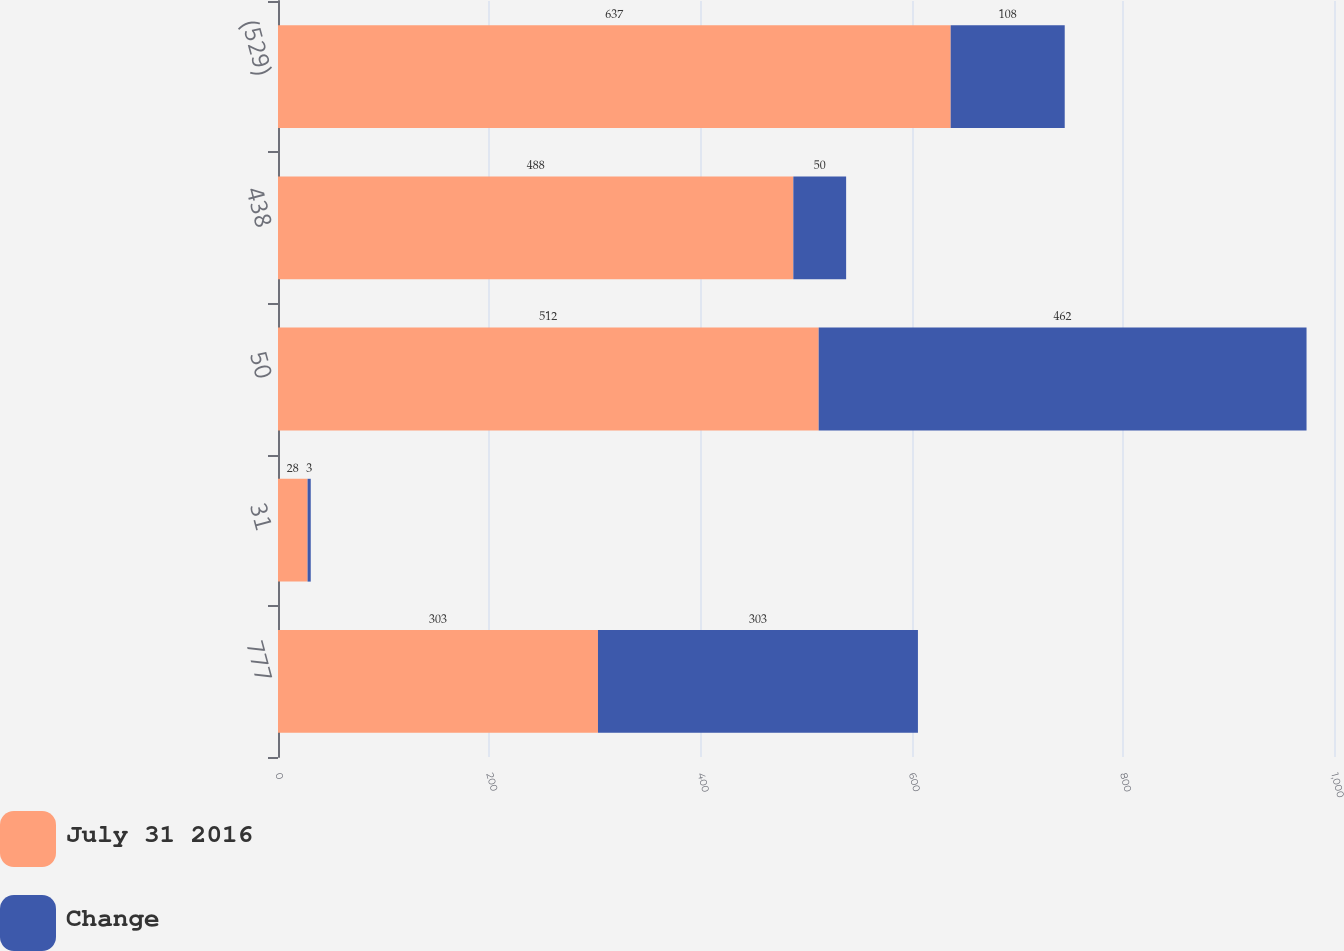<chart> <loc_0><loc_0><loc_500><loc_500><stacked_bar_chart><ecel><fcel>777<fcel>31<fcel>50<fcel>438<fcel>(529)<nl><fcel>July 31 2016<fcel>303<fcel>28<fcel>512<fcel>488<fcel>637<nl><fcel>Change<fcel>303<fcel>3<fcel>462<fcel>50<fcel>108<nl></chart> 